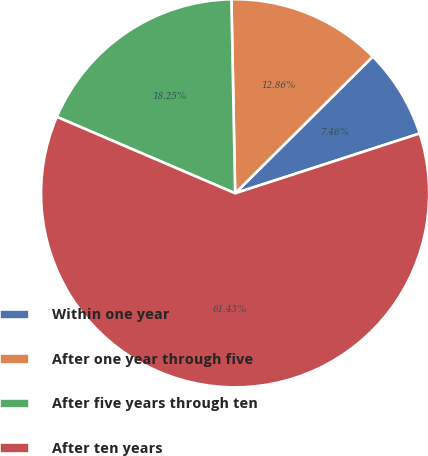<chart> <loc_0><loc_0><loc_500><loc_500><pie_chart><fcel>Within one year<fcel>After one year through five<fcel>After five years through ten<fcel>After ten years<nl><fcel>7.46%<fcel>12.86%<fcel>18.25%<fcel>61.43%<nl></chart> 